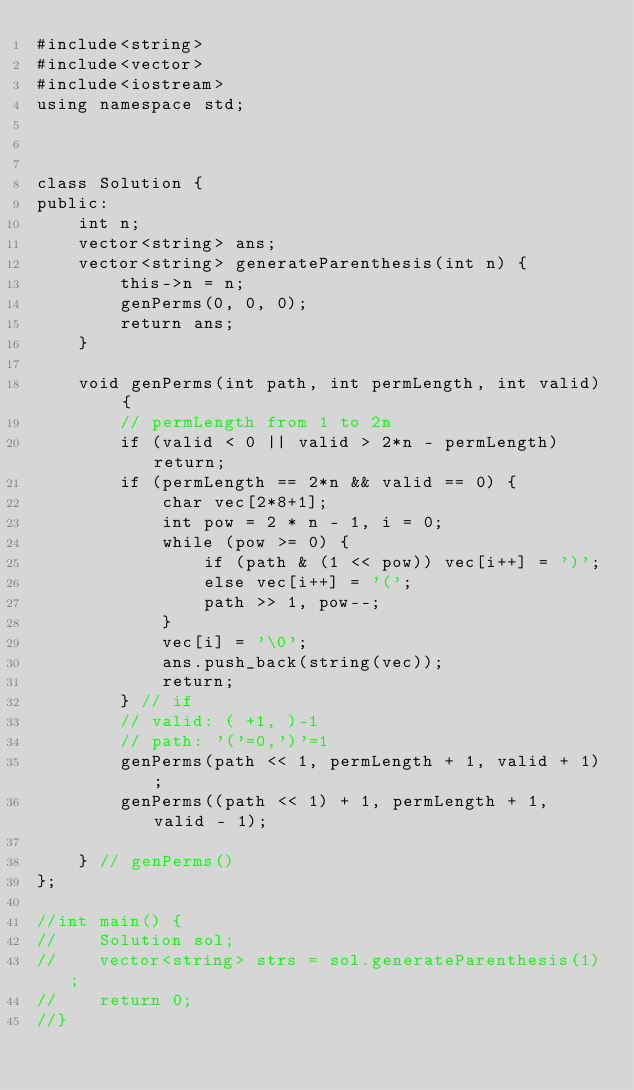<code> <loc_0><loc_0><loc_500><loc_500><_C++_>#include<string>
#include<vector>
#include<iostream>
using namespace std;



class Solution {
public:
    int n;
    vector<string> ans;
    vector<string> generateParenthesis(int n) {
        this->n = n;
        genPerms(0, 0, 0);
        return ans;
    }

    void genPerms(int path, int permLength, int valid) {
        // permLength from 1 to 2n
        if (valid < 0 || valid > 2*n - permLength) return;
        if (permLength == 2*n && valid == 0) {
            char vec[2*8+1];
            int pow = 2 * n - 1, i = 0;
            while (pow >= 0) {
                if (path & (1 << pow)) vec[i++] = ')';
                else vec[i++] = '(';
                path >> 1, pow--;
            }
            vec[i] = '\0';
            ans.push_back(string(vec));
            return;
        } // if
        // valid: ( +1, )-1
        // path: '('=0,')'=1
        genPerms(path << 1, permLength + 1, valid + 1);
        genPerms((path << 1) + 1, permLength + 1, valid - 1);

    } // genPerms()
};

//int main() {
//    Solution sol;
//    vector<string> strs = sol.generateParenthesis(1);
//    return 0;
//}

</code> 